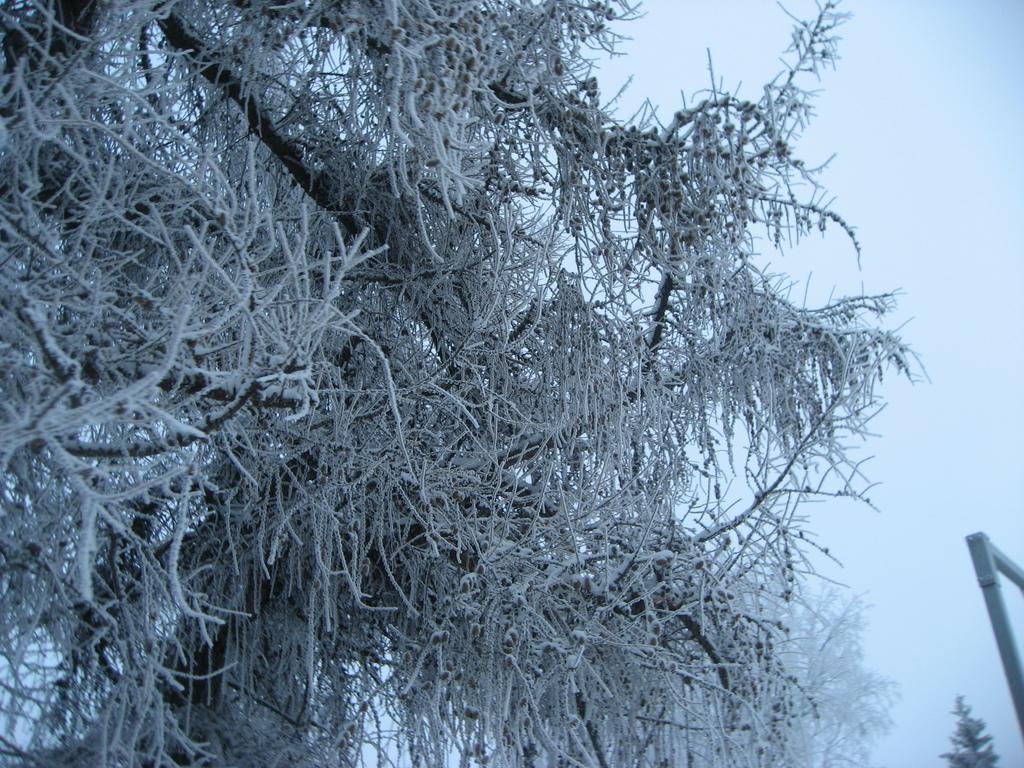Describe this image in one or two sentences. In this image there is snow on the trees. On the right side of the image there is a metal rod. In the background of the image there is sky. 